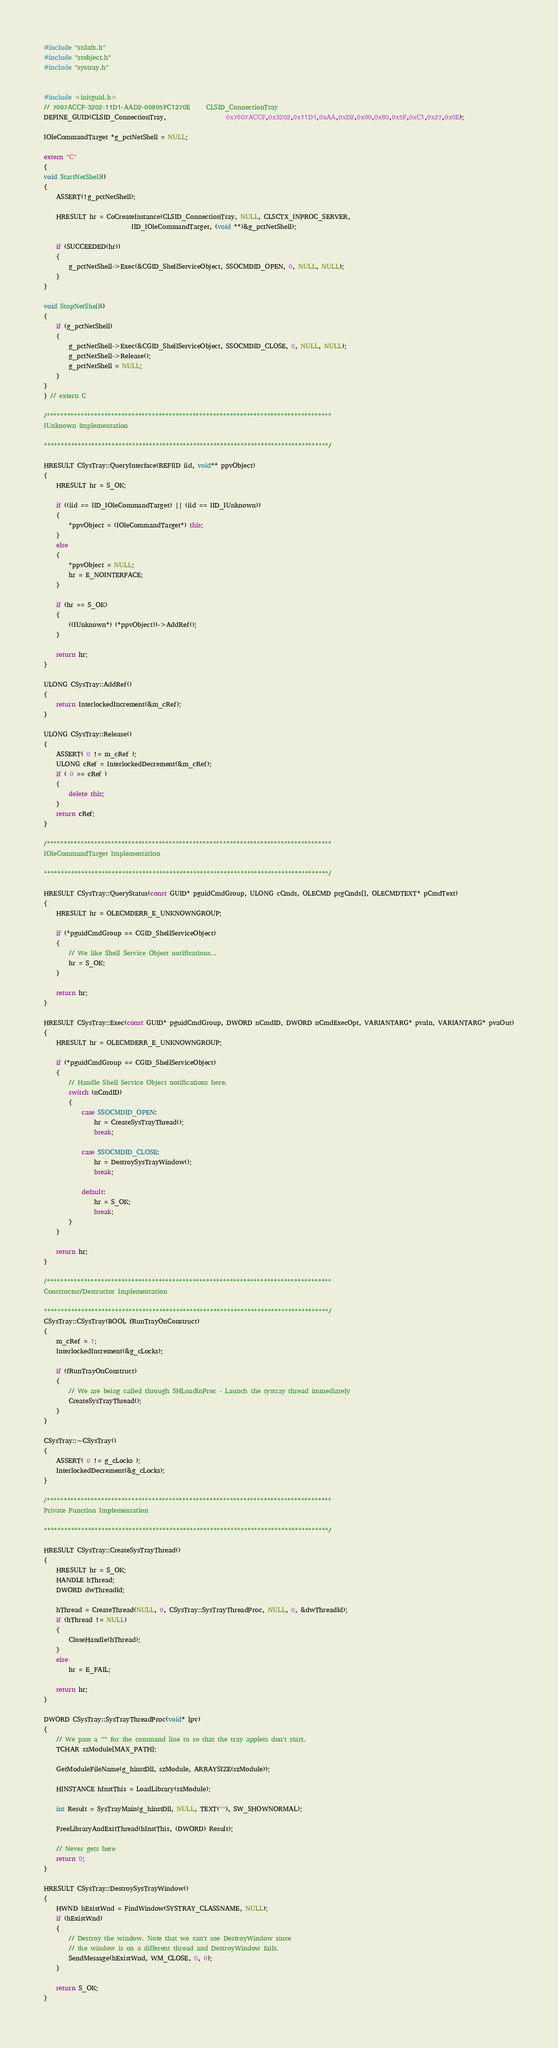Convert code to text. <code><loc_0><loc_0><loc_500><loc_500><_C++_>#include "stdafx.h"
#include "stobject.h"
#include "systray.h"


#include <initguid.h>
// 7007ACCF-3202-11D1-AAD2-00805FC1270E     CLSID_ConnectionTray
DEFINE_GUID(CLSID_ConnectionTray,                   0x7007ACCF,0x3202,0x11D1,0xAA,0xD2,0x00,0x80,0x5F,0xC1,0x27,0x0E);

IOleCommandTarget *g_pctNetShell = NULL;

extern "C"
{
void StartNetShell()
{
    ASSERT(!g_pctNetShell);

    HRESULT hr = CoCreateInstance(CLSID_ConnectionTray, NULL, CLSCTX_INPROC_SERVER,
                            IID_IOleCommandTarget, (void **)&g_pctNetShell);

    if (SUCCEEDED(hr))
    {
        g_pctNetShell->Exec(&CGID_ShellServiceObject, SSOCMDID_OPEN, 0, NULL, NULL);
    }
}

void StopNetShell()
{
    if (g_pctNetShell)
    {
        g_pctNetShell->Exec(&CGID_ShellServiceObject, SSOCMDID_CLOSE, 0, NULL, NULL);
        g_pctNetShell->Release();
        g_pctNetShell = NULL;
    }
}
} // extern C

/************************************************************************************
IUnknown Implementation

************************************************************************************/

HRESULT CSysTray::QueryInterface(REFIID iid, void** ppvObject)
{
    HRESULT hr = S_OK;

    if ((iid == IID_IOleCommandTarget) || (iid == IID_IUnknown))
    {
        *ppvObject = (IOleCommandTarget*) this;
    }
    else
    {
        *ppvObject = NULL;
        hr = E_NOINTERFACE;
    }

    if (hr == S_OK)
    {
        ((IUnknown*) (*ppvObject))->AddRef();
    }

    return hr;
}

ULONG CSysTray::AddRef()
{
    return InterlockedIncrement(&m_cRef);
}

ULONG CSysTray::Release()
{
    ASSERT( 0 != m_cRef );
    ULONG cRef = InterlockedDecrement(&m_cRef);
    if ( 0 == cRef )
    {
        delete this;
    }    
    return cRef;
}

/************************************************************************************
IOleCommandTarget Implementation

************************************************************************************/

HRESULT CSysTray::QueryStatus(const GUID* pguidCmdGroup, ULONG cCmds, OLECMD prgCmds[], OLECMDTEXT* pCmdText)
{
    HRESULT hr = OLECMDERR_E_UNKNOWNGROUP;
 
    if (*pguidCmdGroup == CGID_ShellServiceObject)
    {
        // We like Shell Service Object notifications...
        hr = S_OK;
    }

    return hr;
}

HRESULT CSysTray::Exec(const GUID* pguidCmdGroup, DWORD nCmdID, DWORD nCmdExecOpt, VARIANTARG* pvaIn, VARIANTARG* pvaOut)
{
    HRESULT hr = OLECMDERR_E_UNKNOWNGROUP;

    if (*pguidCmdGroup == CGID_ShellServiceObject)
    {
        // Handle Shell Service Object notifications here.
        switch (nCmdID)
        {
            case SSOCMDID_OPEN:
                hr = CreateSysTrayThread();
                break;

            case SSOCMDID_CLOSE:
                hr = DestroySysTrayWindow();
                break;

            default:
                hr = S_OK;
                break;
        }
    }

    return hr;
}

/************************************************************************************
Constructor/Destructor Implementation

************************************************************************************/
CSysTray::CSysTray(BOOL fRunTrayOnConstruct)
{
    m_cRef = 1;
    InterlockedIncrement(&g_cLocks);

    if (fRunTrayOnConstruct)
    {
        // We are being called through SHLoadInProc - Launch the systray thread immediately
        CreateSysTrayThread();
    }
}

CSysTray::~CSysTray()
{
    ASSERT( 0 != g_cLocks );
    InterlockedDecrement(&g_cLocks);
}

/************************************************************************************
Private Function Implementation

************************************************************************************/

HRESULT CSysTray::CreateSysTrayThread()
{
    HRESULT hr = S_OK;
    HANDLE hThread;
    DWORD dwThreadId;
 
    hThread = CreateThread(NULL, 0, CSysTray::SysTrayThreadProc, NULL, 0, &dwThreadId);
    if (hThread != NULL)
    {
        CloseHandle(hThread);
    }
    else
        hr = E_FAIL;

    return hr;
}

DWORD CSysTray::SysTrayThreadProc(void* lpv)
{
    // We pass a "" for the command line to so that the tray applets don't start.
    TCHAR szModule[MAX_PATH];

    GetModuleFileName(g_hinstDll, szModule, ARRAYSIZE(szModule));

    HINSTANCE hInstThis = LoadLibrary(szModule);

    int Result = SysTrayMain(g_hinstDll, NULL, TEXT(""), SW_SHOWNORMAL);
    
    FreeLibraryAndExitThread(hInstThis, (DWORD) Result);

    // Never gets here
    return 0; 
}

HRESULT CSysTray::DestroySysTrayWindow()
{
    HWND hExistWnd = FindWindow(SYSTRAY_CLASSNAME, NULL);
    if (hExistWnd) 
    {
        // Destroy the window. Note that we can't use DestroyWindow since
        // the window is on a different thread and DestroyWindow fails.
        SendMessage(hExistWnd, WM_CLOSE, 0, 0);
    }

    return S_OK;
}
</code> 